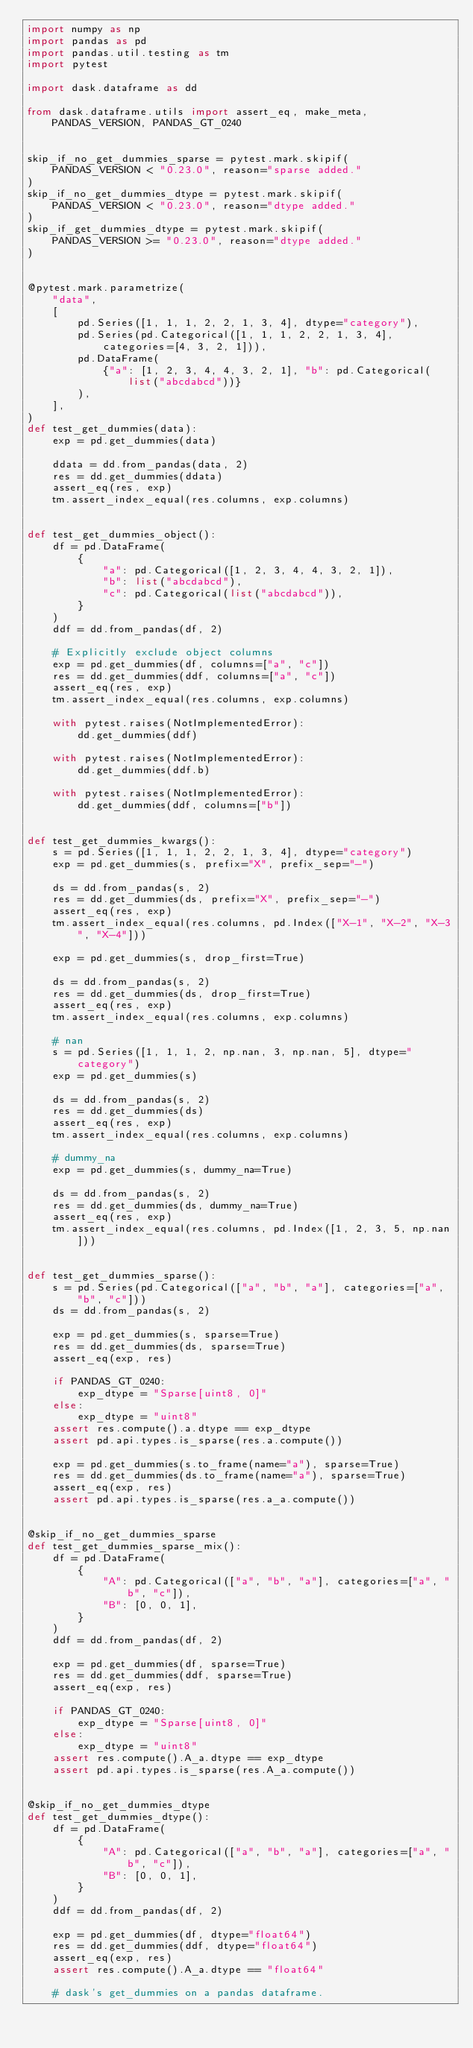<code> <loc_0><loc_0><loc_500><loc_500><_Python_>import numpy as np
import pandas as pd
import pandas.util.testing as tm
import pytest

import dask.dataframe as dd

from dask.dataframe.utils import assert_eq, make_meta, PANDAS_VERSION, PANDAS_GT_0240


skip_if_no_get_dummies_sparse = pytest.mark.skipif(
    PANDAS_VERSION < "0.23.0", reason="sparse added."
)
skip_if_no_get_dummies_dtype = pytest.mark.skipif(
    PANDAS_VERSION < "0.23.0", reason="dtype added."
)
skip_if_get_dummies_dtype = pytest.mark.skipif(
    PANDAS_VERSION >= "0.23.0", reason="dtype added."
)


@pytest.mark.parametrize(
    "data",
    [
        pd.Series([1, 1, 1, 2, 2, 1, 3, 4], dtype="category"),
        pd.Series(pd.Categorical([1, 1, 1, 2, 2, 1, 3, 4], categories=[4, 3, 2, 1])),
        pd.DataFrame(
            {"a": [1, 2, 3, 4, 4, 3, 2, 1], "b": pd.Categorical(list("abcdabcd"))}
        ),
    ],
)
def test_get_dummies(data):
    exp = pd.get_dummies(data)

    ddata = dd.from_pandas(data, 2)
    res = dd.get_dummies(ddata)
    assert_eq(res, exp)
    tm.assert_index_equal(res.columns, exp.columns)


def test_get_dummies_object():
    df = pd.DataFrame(
        {
            "a": pd.Categorical([1, 2, 3, 4, 4, 3, 2, 1]),
            "b": list("abcdabcd"),
            "c": pd.Categorical(list("abcdabcd")),
        }
    )
    ddf = dd.from_pandas(df, 2)

    # Explicitly exclude object columns
    exp = pd.get_dummies(df, columns=["a", "c"])
    res = dd.get_dummies(ddf, columns=["a", "c"])
    assert_eq(res, exp)
    tm.assert_index_equal(res.columns, exp.columns)

    with pytest.raises(NotImplementedError):
        dd.get_dummies(ddf)

    with pytest.raises(NotImplementedError):
        dd.get_dummies(ddf.b)

    with pytest.raises(NotImplementedError):
        dd.get_dummies(ddf, columns=["b"])


def test_get_dummies_kwargs():
    s = pd.Series([1, 1, 1, 2, 2, 1, 3, 4], dtype="category")
    exp = pd.get_dummies(s, prefix="X", prefix_sep="-")

    ds = dd.from_pandas(s, 2)
    res = dd.get_dummies(ds, prefix="X", prefix_sep="-")
    assert_eq(res, exp)
    tm.assert_index_equal(res.columns, pd.Index(["X-1", "X-2", "X-3", "X-4"]))

    exp = pd.get_dummies(s, drop_first=True)

    ds = dd.from_pandas(s, 2)
    res = dd.get_dummies(ds, drop_first=True)
    assert_eq(res, exp)
    tm.assert_index_equal(res.columns, exp.columns)

    # nan
    s = pd.Series([1, 1, 1, 2, np.nan, 3, np.nan, 5], dtype="category")
    exp = pd.get_dummies(s)

    ds = dd.from_pandas(s, 2)
    res = dd.get_dummies(ds)
    assert_eq(res, exp)
    tm.assert_index_equal(res.columns, exp.columns)

    # dummy_na
    exp = pd.get_dummies(s, dummy_na=True)

    ds = dd.from_pandas(s, 2)
    res = dd.get_dummies(ds, dummy_na=True)
    assert_eq(res, exp)
    tm.assert_index_equal(res.columns, pd.Index([1, 2, 3, 5, np.nan]))


def test_get_dummies_sparse():
    s = pd.Series(pd.Categorical(["a", "b", "a"], categories=["a", "b", "c"]))
    ds = dd.from_pandas(s, 2)

    exp = pd.get_dummies(s, sparse=True)
    res = dd.get_dummies(ds, sparse=True)
    assert_eq(exp, res)

    if PANDAS_GT_0240:
        exp_dtype = "Sparse[uint8, 0]"
    else:
        exp_dtype = "uint8"
    assert res.compute().a.dtype == exp_dtype
    assert pd.api.types.is_sparse(res.a.compute())

    exp = pd.get_dummies(s.to_frame(name="a"), sparse=True)
    res = dd.get_dummies(ds.to_frame(name="a"), sparse=True)
    assert_eq(exp, res)
    assert pd.api.types.is_sparse(res.a_a.compute())


@skip_if_no_get_dummies_sparse
def test_get_dummies_sparse_mix():
    df = pd.DataFrame(
        {
            "A": pd.Categorical(["a", "b", "a"], categories=["a", "b", "c"]),
            "B": [0, 0, 1],
        }
    )
    ddf = dd.from_pandas(df, 2)

    exp = pd.get_dummies(df, sparse=True)
    res = dd.get_dummies(ddf, sparse=True)
    assert_eq(exp, res)

    if PANDAS_GT_0240:
        exp_dtype = "Sparse[uint8, 0]"
    else:
        exp_dtype = "uint8"
    assert res.compute().A_a.dtype == exp_dtype
    assert pd.api.types.is_sparse(res.A_a.compute())


@skip_if_no_get_dummies_dtype
def test_get_dummies_dtype():
    df = pd.DataFrame(
        {
            "A": pd.Categorical(["a", "b", "a"], categories=["a", "b", "c"]),
            "B": [0, 0, 1],
        }
    )
    ddf = dd.from_pandas(df, 2)

    exp = pd.get_dummies(df, dtype="float64")
    res = dd.get_dummies(ddf, dtype="float64")
    assert_eq(exp, res)
    assert res.compute().A_a.dtype == "float64"

    # dask's get_dummies on a pandas dataframe.</code> 